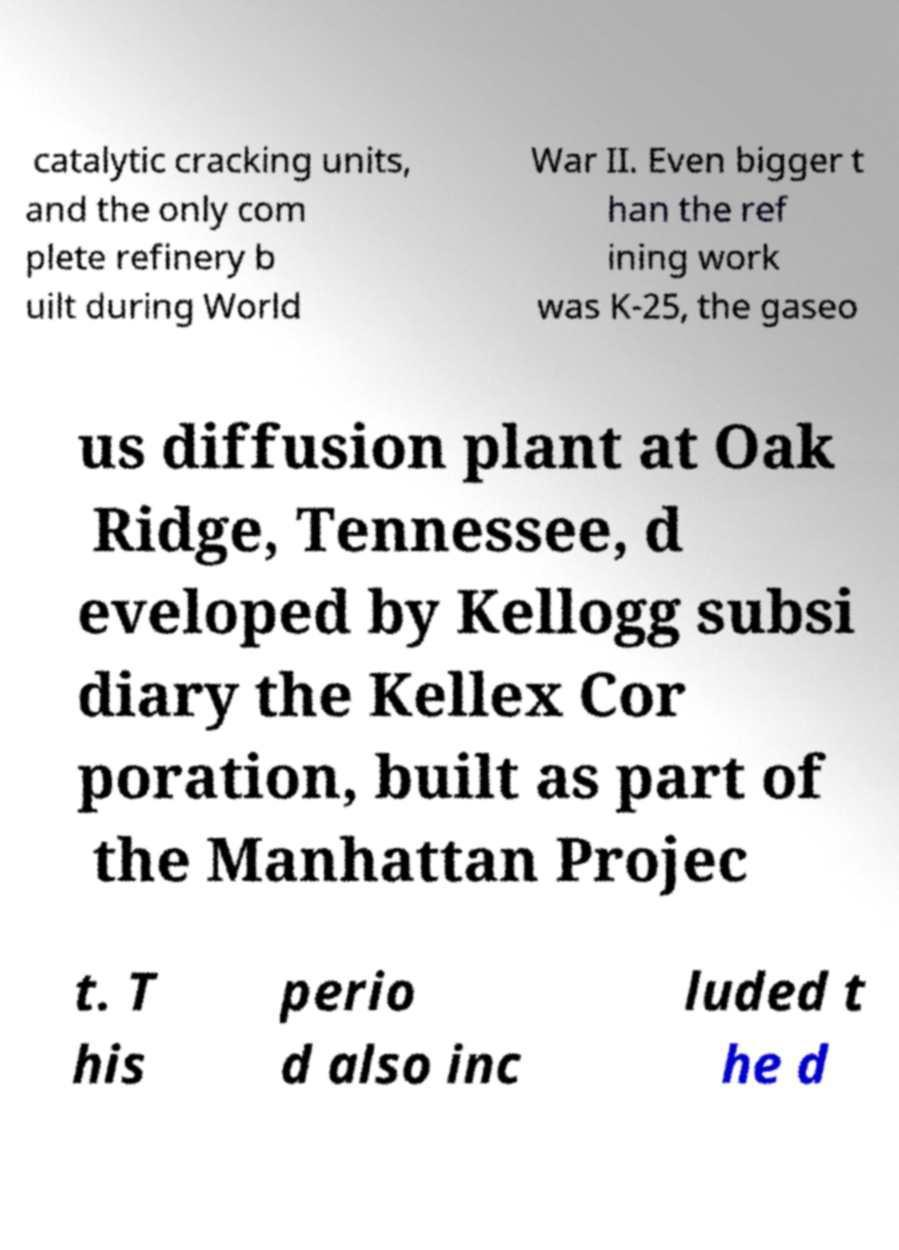Could you extract and type out the text from this image? catalytic cracking units, and the only com plete refinery b uilt during World War II. Even bigger t han the ref ining work was K-25, the gaseo us diffusion plant at Oak Ridge, Tennessee, d eveloped by Kellogg subsi diary the Kellex Cor poration, built as part of the Manhattan Projec t. T his perio d also inc luded t he d 